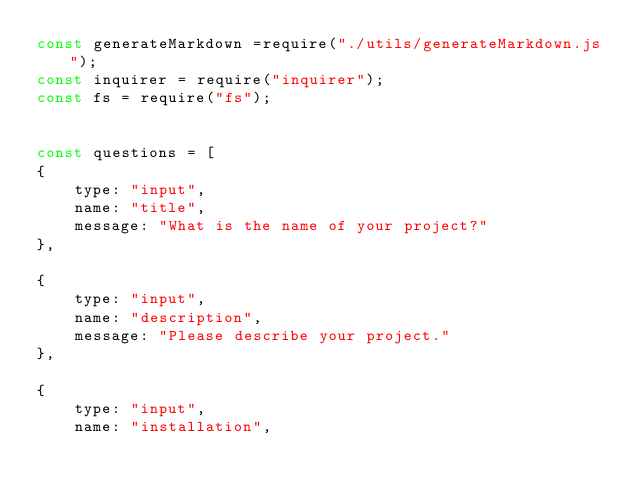<code> <loc_0><loc_0><loc_500><loc_500><_JavaScript_>const generateMarkdown =require("./utils/generateMarkdown.js");
const inquirer = require("inquirer");
const fs = require("fs");


const questions = [
{
    type: "input",
    name: "title",
    message: "What is the name of your project?"
},

{
    type: "input",
    name: "description",
    message: "Please describe your project."
},

{
    type: "input",
    name: "installation",</code> 